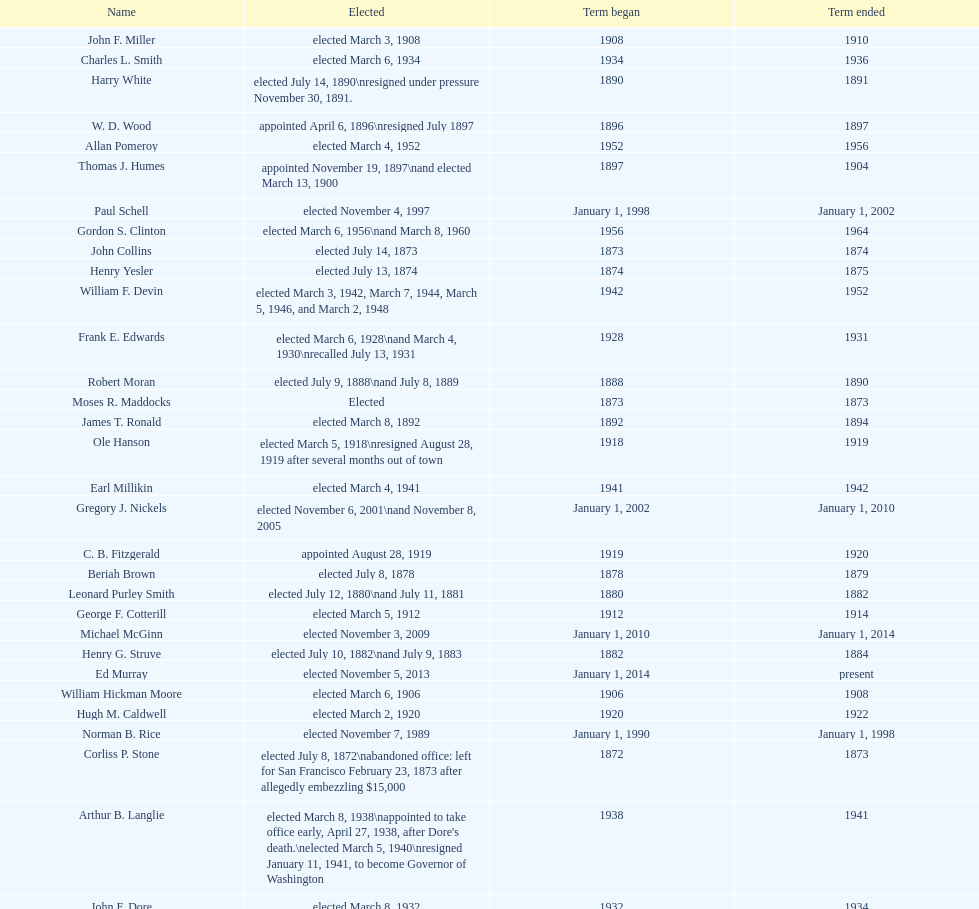Could you help me parse every detail presented in this table? {'header': ['Name', 'Elected', 'Term began', 'Term ended'], 'rows': [['John F. Miller', 'elected March 3, 1908', '1908', '1910'], ['Charles L. Smith', 'elected March 6, 1934', '1934', '1936'], ['Harry White', 'elected July 14, 1890\\nresigned under pressure November 30, 1891.', '1890', '1891'], ['W. D. Wood', 'appointed April 6, 1896\\nresigned July 1897', '1896', '1897'], ['Allan Pomeroy', 'elected March 4, 1952', '1952', '1956'], ['Thomas J. Humes', 'appointed November 19, 1897\\nand elected March 13, 1900', '1897', '1904'], ['Paul Schell', 'elected November 4, 1997', 'January 1, 1998', 'January 1, 2002'], ['Gordon S. Clinton', 'elected March 6, 1956\\nand March 8, 1960', '1956', '1964'], ['John Collins', 'elected July 14, 1873', '1873', '1874'], ['Henry Yesler', 'elected July 13, 1874', '1874', '1875'], ['William F. Devin', 'elected March 3, 1942, March 7, 1944, March 5, 1946, and March 2, 1948', '1942', '1952'], ['Frank E. Edwards', 'elected March 6, 1928\\nand March 4, 1930\\nrecalled July 13, 1931', '1928', '1931'], ['Robert Moran', 'elected July 9, 1888\\nand July 8, 1889', '1888', '1890'], ['Moses R. Maddocks', 'Elected', '1873', '1873'], ['James T. Ronald', 'elected March 8, 1892', '1892', '1894'], ['Ole Hanson', 'elected March 5, 1918\\nresigned August 28, 1919 after several months out of town', '1918', '1919'], ['Earl Millikin', 'elected March 4, 1941', '1941', '1942'], ['Gregory J. Nickels', 'elected November 6, 2001\\nand November 8, 2005', 'January 1, 2002', 'January 1, 2010'], ['C. B. Fitzgerald', 'appointed August 28, 1919', '1919', '1920'], ['Beriah Brown', 'elected July 8, 1878', '1878', '1879'], ['Leonard Purley Smith', 'elected July 12, 1880\\nand July 11, 1881', '1880', '1882'], ['George F. Cotterill', 'elected March 5, 1912', '1912', '1914'], ['Michael McGinn', 'elected November 3, 2009', 'January 1, 2010', 'January 1, 2014'], ['Henry G. Struve', 'elected July 10, 1882\\nand July 9, 1883', '1882', '1884'], ['Ed Murray', 'elected November 5, 2013', 'January 1, 2014', 'present'], ['William Hickman Moore', 'elected March 6, 1906', '1906', '1908'], ['Hugh M. Caldwell', 'elected March 2, 1920', '1920', '1922'], ['Norman B. Rice', 'elected November 7, 1989', 'January 1, 1990', 'January 1, 1998'], ['Corliss P. Stone', 'elected July 8, 1872\\nabandoned office: left for San Francisco February 23, 1873 after allegedly embezzling $15,000', '1872', '1873'], ['Arthur B. Langlie', "elected March 8, 1938\\nappointed to take office early, April 27, 1938, after Dore's death.\\nelected March 5, 1940\\nresigned January 11, 1941, to become Governor of Washington", '1938', '1941'], ['John F. Dore', 'elected March 8, 1932', '1932', '1934'], ['George W. Hall', 'appointed December 9, 1891', '1891', '1892'], ['Gideon A. Weed', 'elected July 10, 1876\\nand July 9, 1877', '1876', '1878'], ['Hiram C. Gill', 'elected March 8, 1910\\nrecalled February 9, 1911', '1910', '1911'], ['John T. Jordan', 'elected July 10, 1871', '1871', '1872'], ['Henry A. Atkins', 'appointed December 2, 1869\\nelected July 11, 1870', '1869', '1871'], ['Wesley C. Uhlman', 'elected November 4, 1969\\nand November 6, 1973\\nsurvived recall attempt on July 1, 1975', 'December 1, 1969', 'January 1, 1978'], ["James d'Orma Braman", 'elected March 10, 1964\\nresigned March 23, 1969, to accept an appointment as an Assistant Secretary in the Department of Transportation in the Nixon administration.', '1964', '1969'], ['William H. Shoudy', 'elected July 12, 1886', '1886', '1887'], ['Orange Jacobs', 'elected July 14, 1879', '1879', '1880'], ['Bailey Gatzert', 'elected August 2, 1875', '1875', '1876'], ['Edwin J. Brown', 'elected May 2, 1922\\nand March 4, 1924', '1922', '1926'], ['Bertha Knight Landes', 'elected March 9, 1926', '1926', '1928'], ['George W. Dilling', 'appointed February 10, 1911[citation needed]', '1912', ''], ['Hiram C. Gill', 'elected March 3, 1914', '1914', '1918'], ['Floyd C. Miller', 'appointed March 23, 1969', '1969', '1969'], ['John E. Carroll', 'appointed January 27, 1941', '1941', '1941'], ['John T. Jordan', 'appointed', '1873', '1873'], ['Henry Yesler', 'elected July 13, 1885', '1885', '1886'], ['Robert H. Harlin', 'appointed July 14, 1931', '1931', '1932'], ['Richard A. Ballinger', 'elected March 8, 1904', '1904', '1906'], ['John Leary', 'elected July 14, 1884', '1884', '1885'], ['John F. Dore', 'elected March 3, 1936\\nbecame gravely ill and was relieved of office April 13, 1938, already a lame duck after the 1938 election. He died five days later.', '1936', '1938'], ['Frank D. Black', 'elected March 9, 1896\\nresigned after three weeks in office', '1896', '1896'], ['Dr. Thomas T. Minor', 'elected July 11, 1887', '1887', '1888'], ['Charles Royer', 'elected November 8, 1977, November 3, 1981, and November 5, 1985', 'January 1, 1978', 'January 1, 1990'], ['Byron Phelps', 'elected March 12, 1894', '1894', '1896']]} Which mayor seattle, washington resigned after only three weeks in office in 1896? Frank D. Black. 